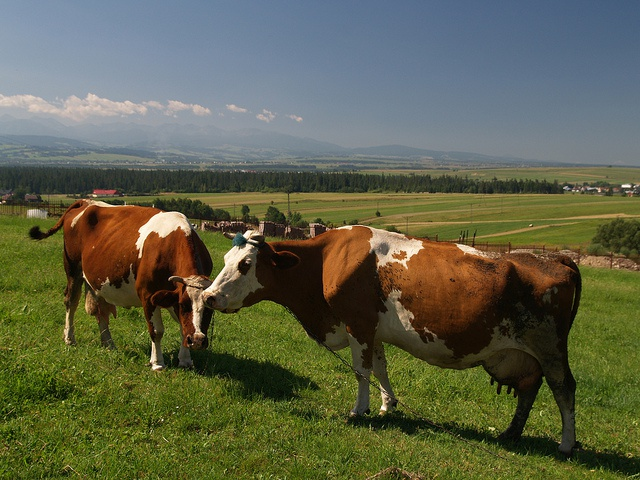Describe the objects in this image and their specific colors. I can see cow in darkgray, black, brown, maroon, and olive tones and cow in darkgray, black, maroon, brown, and olive tones in this image. 